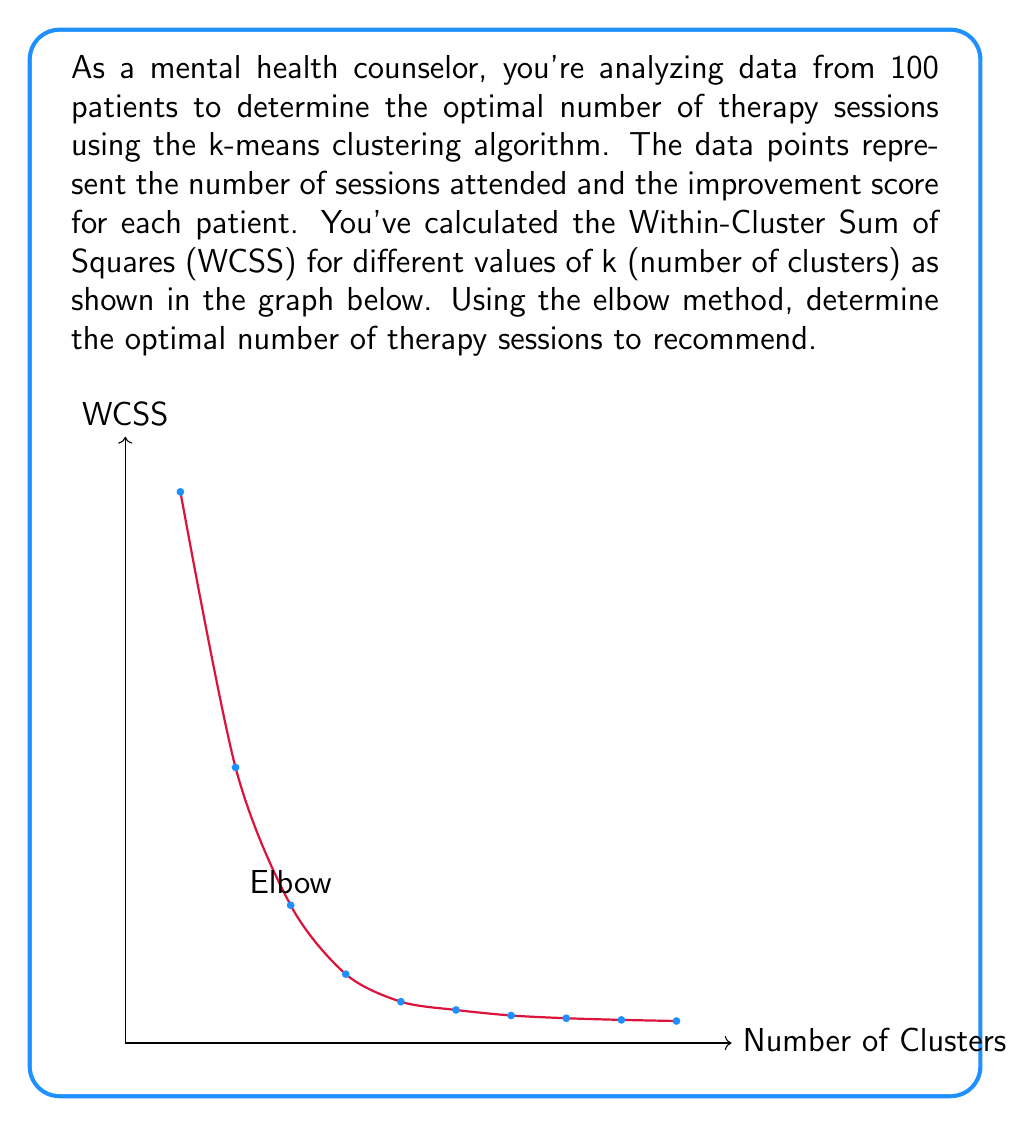Can you solve this math problem? To determine the optimal number of therapy sessions using the k-means clustering algorithm and the elbow method, we follow these steps:

1. Understand the elbow method: It's a technique used to find the optimal number of clusters by plotting the WCSS against the number of clusters (k) and looking for the "elbow" point.

2. Analyze the graph:
   - The x-axis represents the number of clusters (k)
   - The y-axis represents the Within-Cluster Sum of Squares (WCSS)
   - As k increases, WCSS generally decreases

3. Identify the elbow point:
   - Look for the point where the rate of decrease in WCSS sharply changes
   - This point represents the optimal number of clusters
   - In the given graph, we can see a clear elbow at k = 3

4. Interpret the result:
   - The elbow at k = 3 suggests that 3 is the optimal number of clusters
   - Each cluster represents a group of patients with similar therapy session needs and improvement scores

5. Translate to therapy sessions:
   - As a mental health counselor, you can interpret these 3 clusters as representing short-term, medium-term, and long-term therapy needs
   - The optimal number of therapy sessions to recommend would be 3, corresponding to these three categories

Therefore, based on the elbow method applied to the k-means clustering results, the optimal number of therapy sessions to recommend is 3.
Answer: 3 sessions 